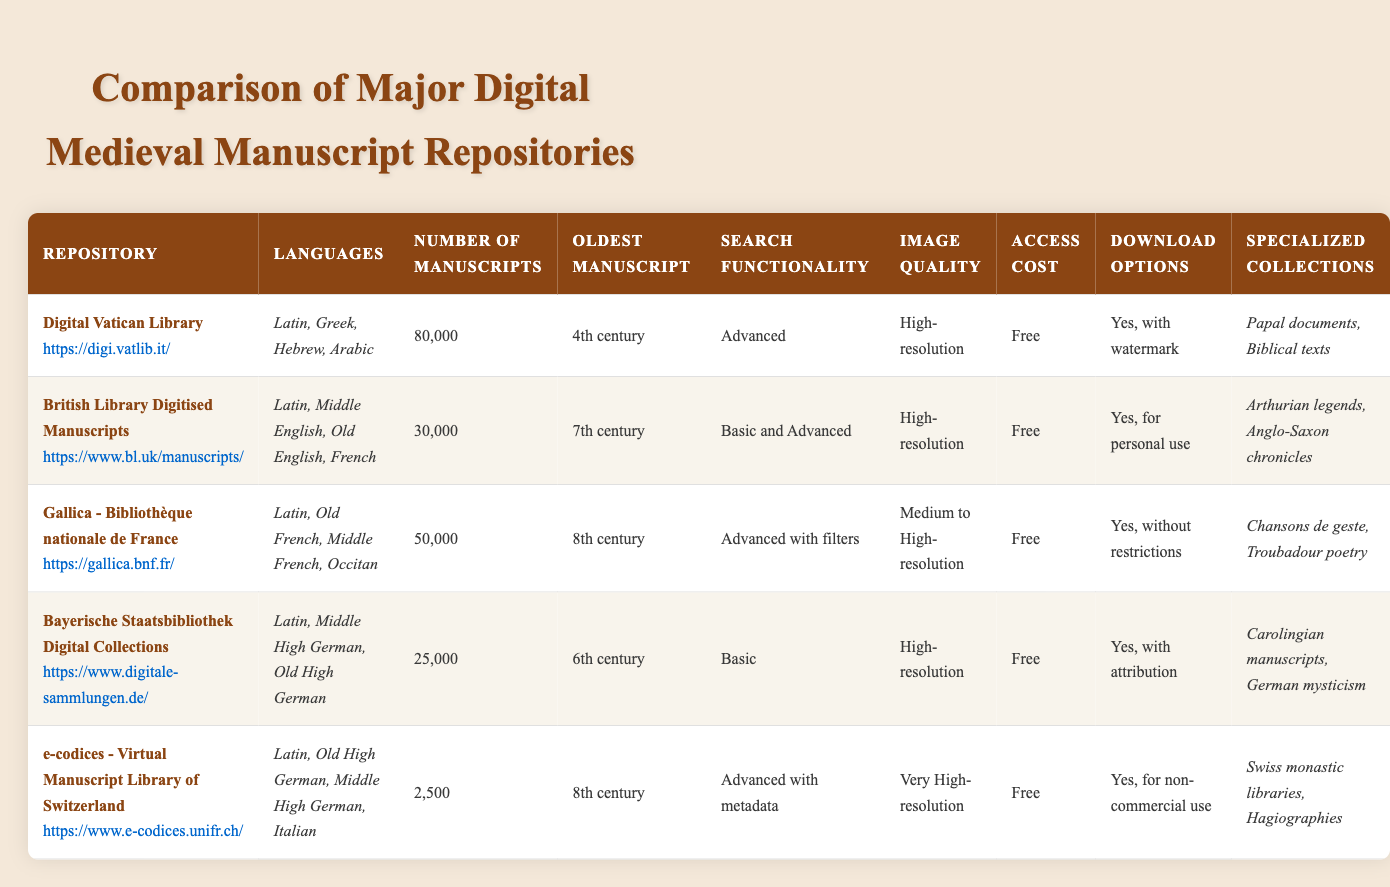How many manuscripts are available in the Digital Vatican Library? The table indicates that the Digital Vatican Library has a total of 80,000 manuscripts listed under the "Number of Manuscripts" column.
Answer: 80,000 Which repository includes the oldest manuscript from the 4th century? The table shows that the Digital Vatican Library has the oldest manuscript dating back to the 4th century, as highlighted in the "Oldest Manuscript" column.
Answer: Digital Vatican Library What is the average number of manuscripts across all repositories? By summing the number of manuscripts for each repository (80,000 + 30,000 + 50,000 + 25,000 + 2,500 = 187,500) and dividing by the number of repositories (5), the average is 187,500 / 5 = 37,500.
Answer: 37,500 Does the Bayerische Staatsbibliothek Digital Collections offer high-resolution images? The table clearly states under "Image Quality" for Bayerische Staatsbibliothek Digital Collections that it provides high-resolution images. Therefore, the answer is yes.
Answer: Yes Which repository has the most specialized collections listed? By reviewing the "Specialized Collections" column, the Digital Vatican Library lists two specialized collections, while the British Library has two as well, Gallica has two, Bayerische Staatsbibliothek lists two, and e-codices lists two. Hence, no repository has more than two.
Answer: None Is it true that all repositories listed in the table are free to access? The "Access Cost" column indicates that all repositories have an access cost listed as "Free," confirming that this statement is true.
Answer: True What is the difference in the number of manuscripts between the British Library and the Gallica repository? Looking at the table, the British Library has 30,000 manuscripts and Gallica has 50,000 manuscripts. The difference is 50,000 - 30,000 = 20,000 manuscripts.
Answer: 20,000 Which repository offers download options without restrictions? According to the "Download Options" column, Gallica - Bibliothèque nationale de France is the only repository that specifies "Yes, without restrictions" for downloads.
Answer: Gallica - Bibliothèque nationale de France 